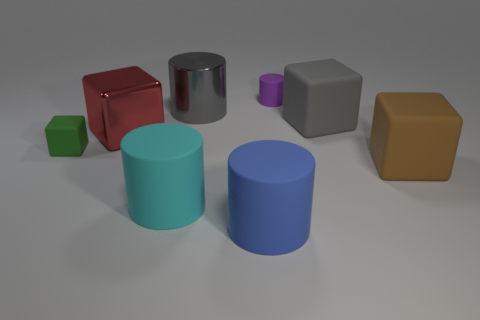Subtract all metal blocks. How many blocks are left? 3 Add 1 big brown matte objects. How many objects exist? 9 Subtract all red blocks. How many blocks are left? 3 Add 2 gray metallic objects. How many gray metallic objects exist? 3 Subtract 0 brown cylinders. How many objects are left? 8 Subtract all brown cubes. Subtract all gray cylinders. How many cubes are left? 3 Subtract all large blue rubber objects. Subtract all big brown metal objects. How many objects are left? 7 Add 7 big blue rubber cylinders. How many big blue rubber cylinders are left? 8 